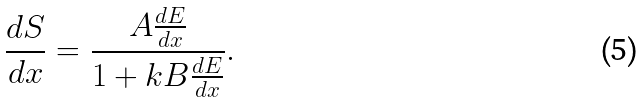Convert formula to latex. <formula><loc_0><loc_0><loc_500><loc_500>\frac { d S } { d x } = \frac { A \frac { d E } { d x } } { 1 + k B \frac { d E } { d x } } .</formula> 